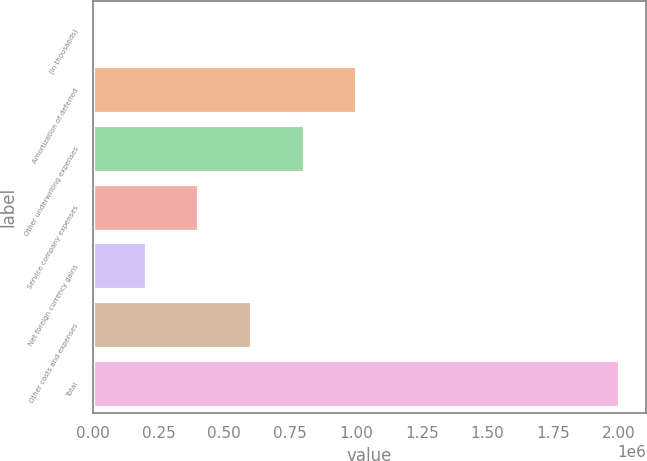Convert chart. <chart><loc_0><loc_0><loc_500><loc_500><bar_chart><fcel>(In thousands)<fcel>Amortization of deferred<fcel>Other underwriting expenses<fcel>Service company expenses<fcel>Net foreign currency gains<fcel>Other costs and expenses<fcel>Total<nl><fcel>2013<fcel>1.00135e+06<fcel>801481<fcel>401747<fcel>201880<fcel>601614<fcel>2.00068e+06<nl></chart> 